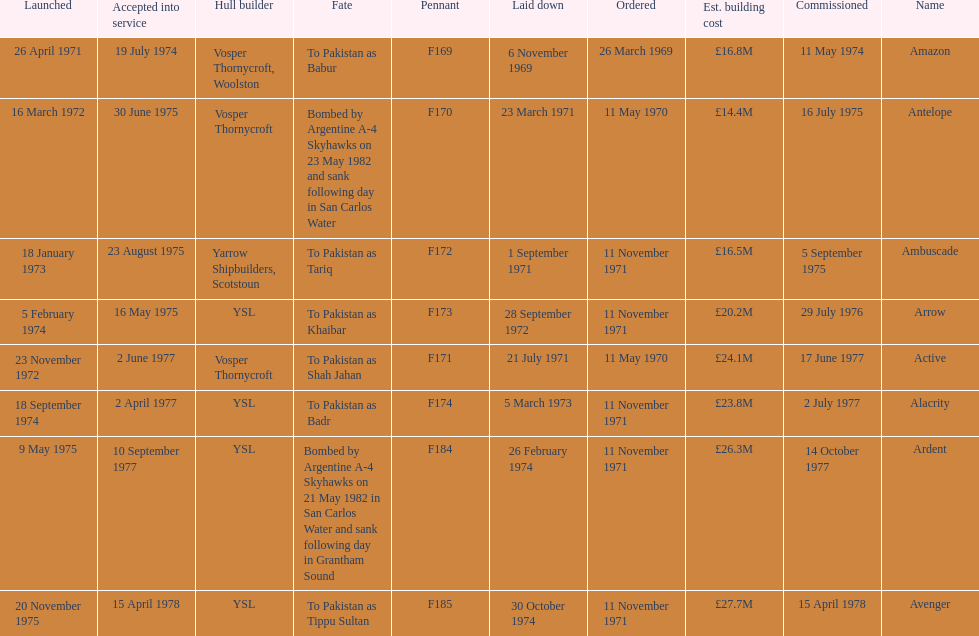How many ships were laid down in september? 2. 